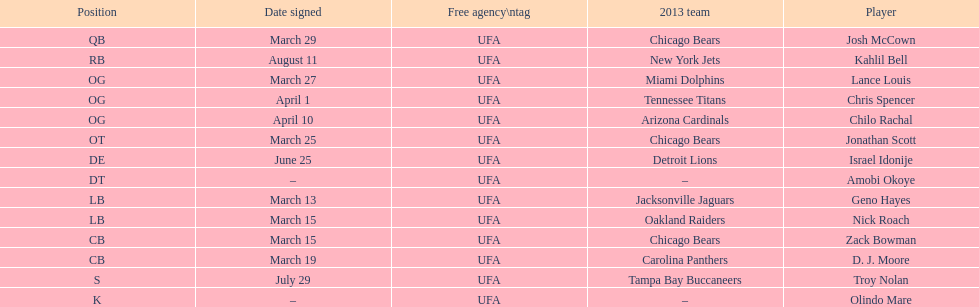His/her first name is the same name as a country. Israel Idonije. 